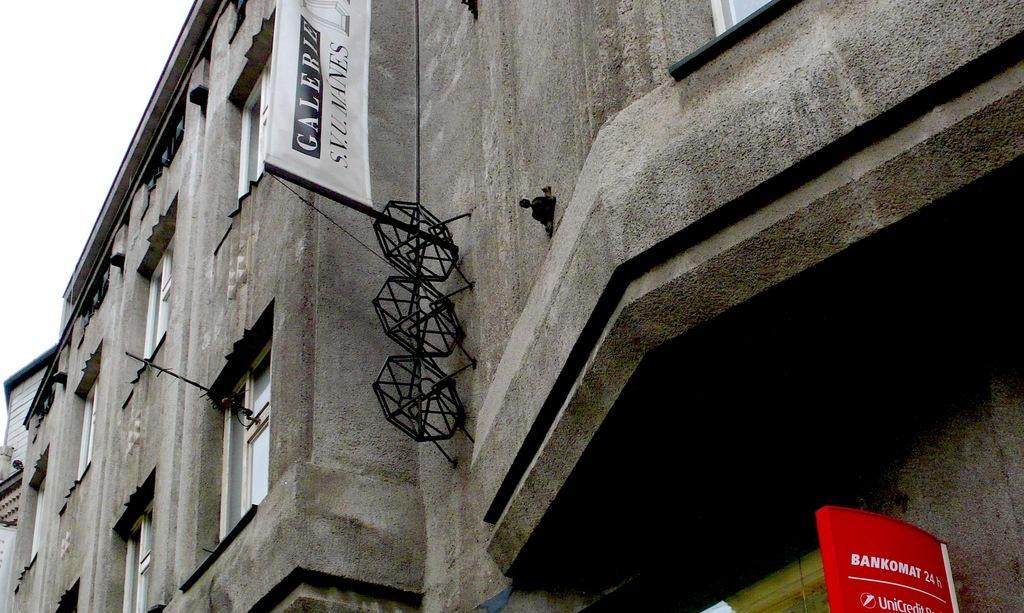Please provide a concise description of this image. In this image we can see a building and the sky is in the background. 